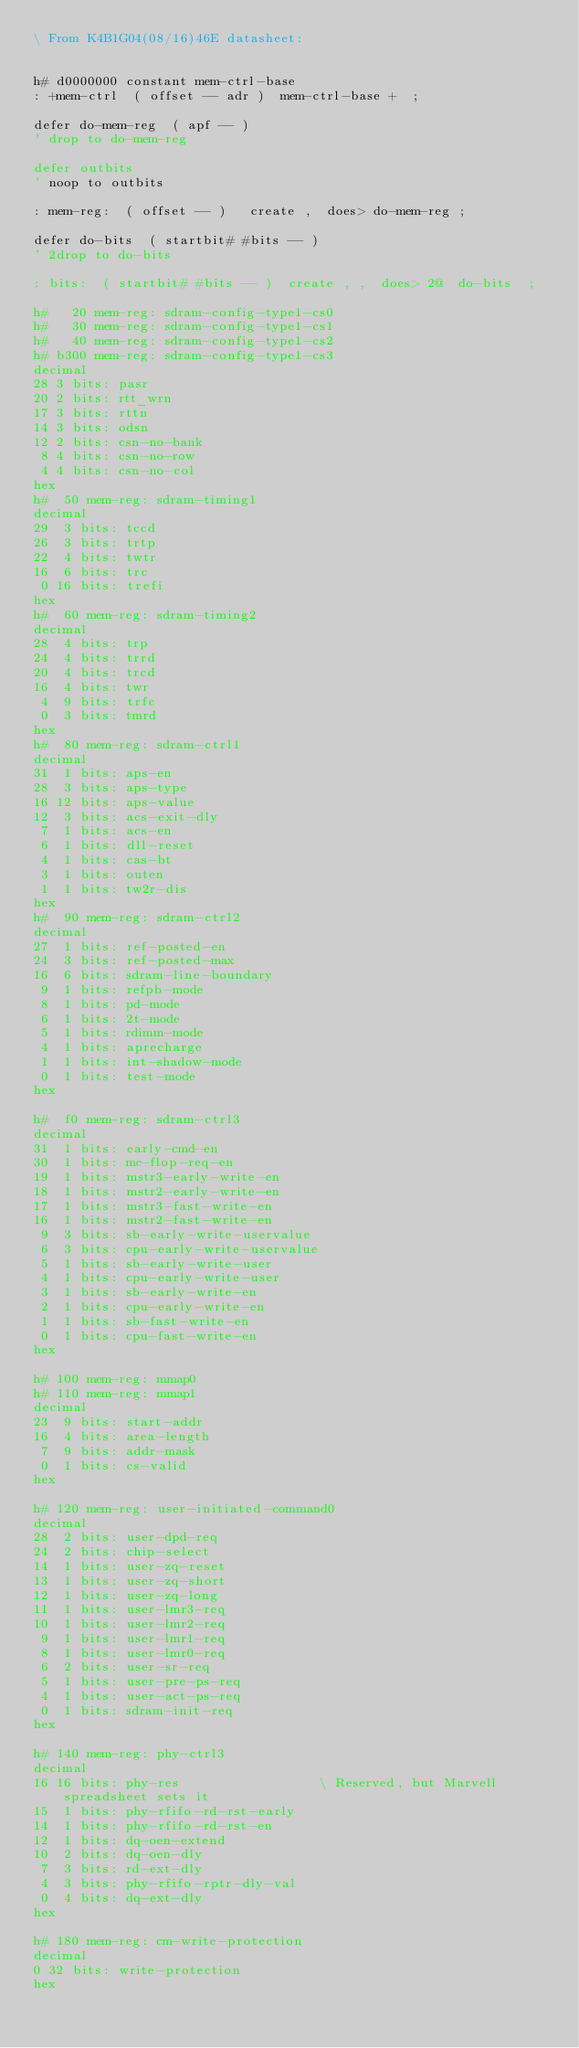Convert code to text. <code><loc_0><loc_0><loc_500><loc_500><_Forth_>\ From K4B1G04(08/16)46E datasheet:


h# d0000000 constant mem-ctrl-base
: +mem-ctrl  ( offset -- adr )  mem-ctrl-base +  ;

defer do-mem-reg  ( apf -- )
' drop to do-mem-reg

defer outbits
' noop to outbits

: mem-reg:  ( offset -- )   create ,  does> do-mem-reg ;

defer do-bits  ( startbit# #bits -- )
' 2drop to do-bits

: bits:  ( startbit# #bits -- )  create , ,  does> 2@  do-bits  ;

h#   20 mem-reg: sdram-config-type1-cs0
h#   30 mem-reg: sdram-config-type1-cs1
h#   40 mem-reg: sdram-config-type1-cs2
h# b300 mem-reg: sdram-config-type1-cs3
decimal
28 3 bits: pasr
20 2 bits: rtt_wrn
17 3 bits: rttn
14 3 bits: odsn
12 2 bits: csn-no-bank
 8 4 bits: csn-no-row
 4 4 bits: csn-no-col
hex
h#  50 mem-reg: sdram-timing1
decimal
29  3 bits: tccd
26  3 bits: trtp
22  4 bits: twtr
16  6 bits: trc
 0 16 bits: trefi
hex
h#  60 mem-reg: sdram-timing2
decimal
28  4 bits: trp
24  4 bits: trrd
20  4 bits: trcd
16  4 bits: twr
 4  9 bits: trfc
 0  3 bits: tmrd
hex
h#  80 mem-reg: sdram-ctrl1
decimal
31  1 bits: aps-en
28  3 bits: aps-type
16 12 bits: aps-value
12  3 bits: acs-exit-dly
 7  1 bits: acs-en
 6  1 bits: dll-reset
 4  1 bits: cas-bt
 3  1 bits: outen
 1  1 bits: tw2r-dis
hex
h#  90 mem-reg: sdram-ctrl2
decimal
27  1 bits: ref-posted-en
24  3 bits: ref-posted-max
16  6 bits: sdram-line-boundary
 9  1 bits: refpb-mode
 8  1 bits: pd-mode
 6  1 bits: 2t-mode
 5  1 bits: rdimm-mode
 4  1 bits: aprecharge
 1  1 bits: int-shadow-mode
 0  1 bits: test-mode
hex

h#  f0 mem-reg: sdram-ctrl3
decimal
31  1 bits: early-cmd-en
30  1 bits: mc-flop-req-en
19  1 bits: mstr3-early-write-en
18  1 bits: mstr2-early-write-en
17  1 bits: mstr3-fast-write-en
16  1 bits: mstr2-fast-write-en
 9  3 bits: sb-early-write-uservalue
 6  3 bits: cpu-early-write-uservalue
 5  1 bits: sb-early-write-user
 4  1 bits: cpu-early-write-user
 3  1 bits: sb-early-write-en
 2  1 bits: cpu-early-write-en
 1  1 bits: sb-fast-write-en
 0  1 bits: cpu-fast-write-en
hex

h# 100 mem-reg: mmap0
h# 110 mem-reg: mmap1
decimal
23  9 bits: start-addr
16  4 bits: area-length
 7  9 bits: addr-mask
 0  1 bits: cs-valid
hex

h# 120 mem-reg: user-initiated-command0
decimal
28  2 bits: user-dpd-req
24  2 bits: chip-select
14  1 bits: user-zq-reset
13  1 bits: user-zq-short
12  1 bits: user-zq-long
11  1 bits: user-lmr3-req
10  1 bits: user-lmr2-req
 9  1 bits: user-lmr1-req
 8  1 bits: user-lmr0-req
 6  2 bits: user-sr-req
 5  1 bits: user-pre-ps-req
 4  1 bits: user-act-ps-req
 0  1 bits: sdram-init-req
hex

h# 140 mem-reg: phy-ctrl3
decimal
16 16 bits: phy-res                  \ Reserved, but Marvell spreadsheet sets it
15  1 bits: phy-rfifo-rd-rst-early
14  1 bits: phy-rfifo-rd-rst-en
12  1 bits: dq-oen-extend
10  2 bits: dq-oen-dly
 7  3 bits: rd-ext-dly
 4  3 bits: phy-rfifo-rptr-dly-val
 0  4 bits: dq-ext-dly
hex

h# 180 mem-reg: cm-write-protection
decimal
0 32 bits: write-protection
hex
</code> 